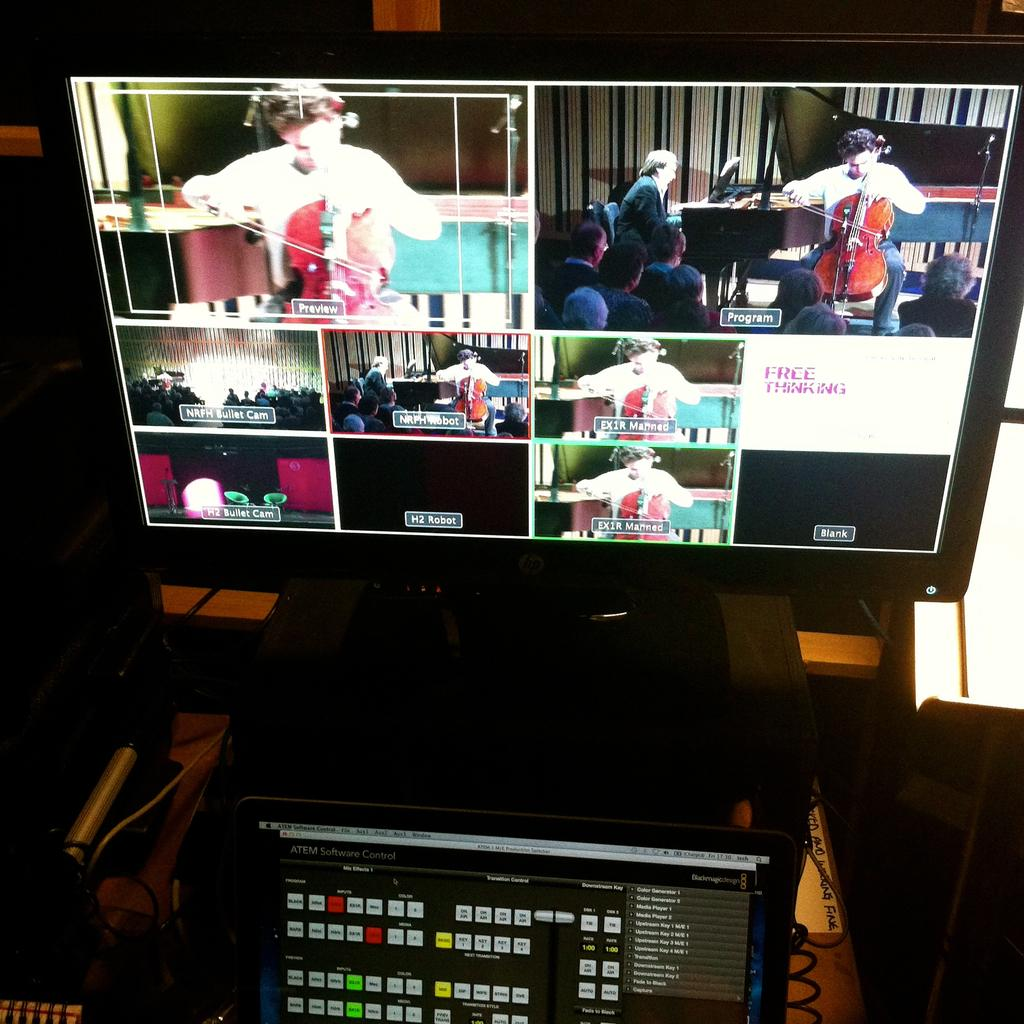Provide a one-sentence caption for the provided image. A monitor displays a number of boxes, one box reads "free thinking.". 